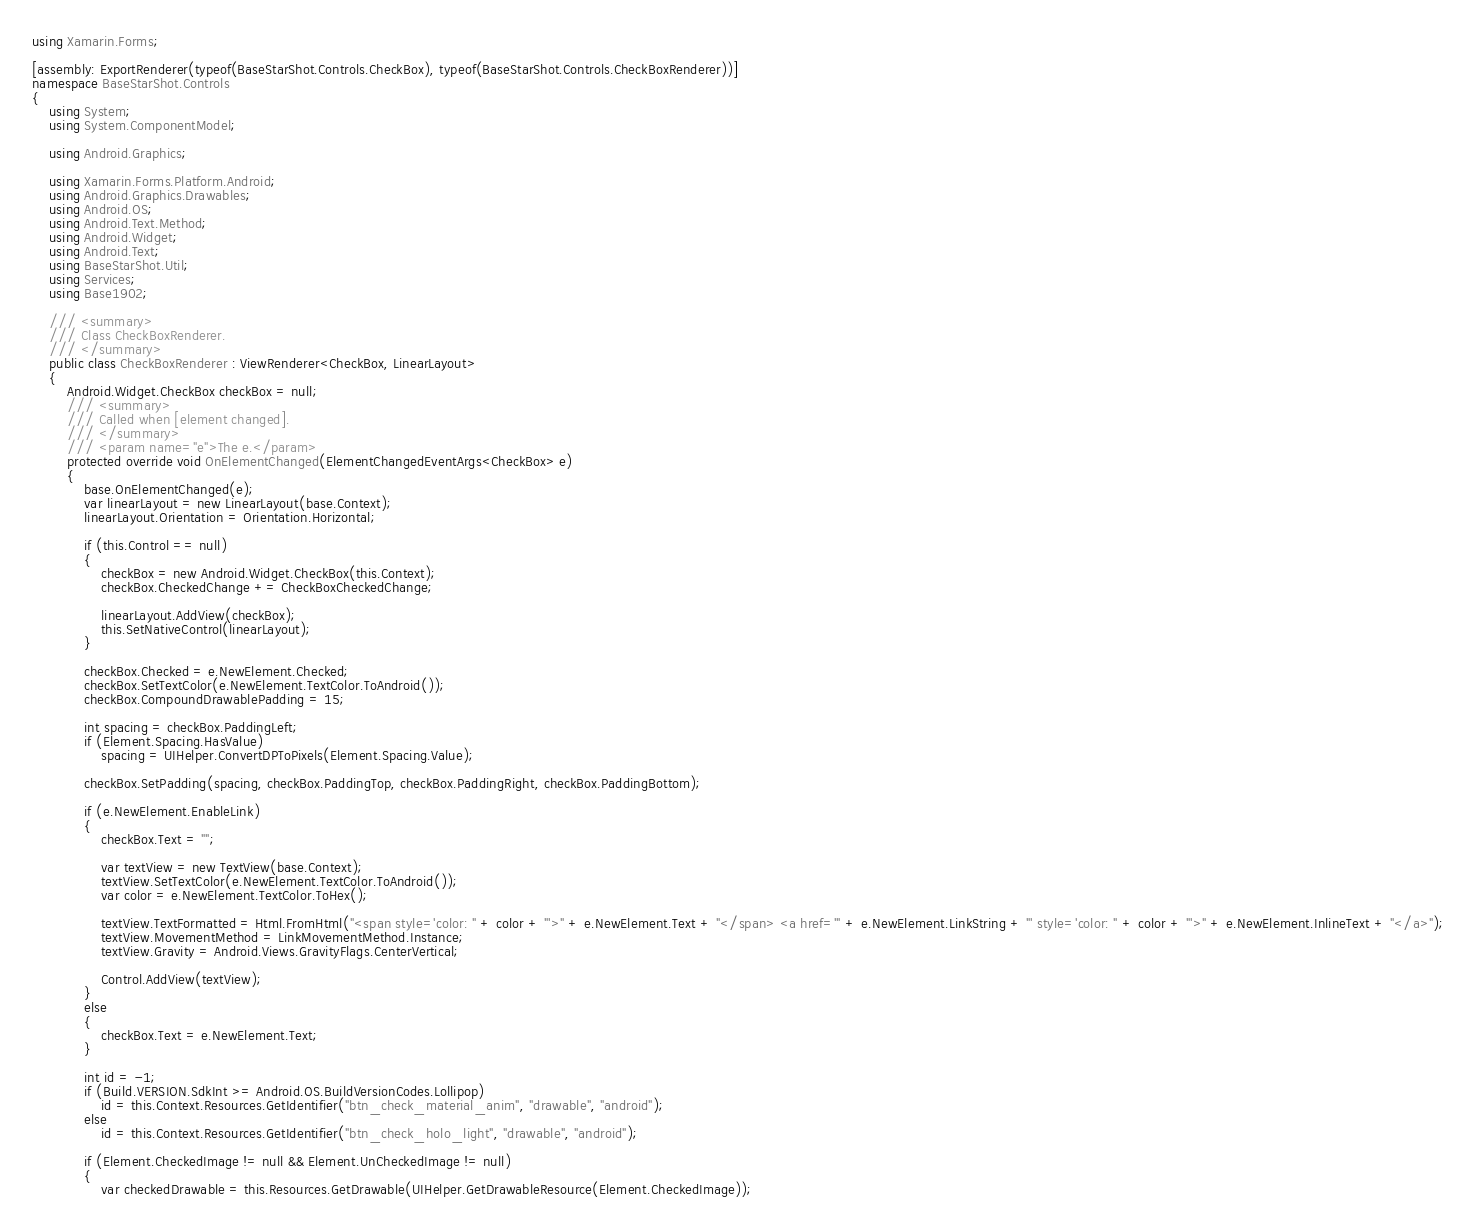<code> <loc_0><loc_0><loc_500><loc_500><_C#_>using Xamarin.Forms;

[assembly: ExportRenderer(typeof(BaseStarShot.Controls.CheckBox), typeof(BaseStarShot.Controls.CheckBoxRenderer))]
namespace BaseStarShot.Controls
{
    using System;
    using System.ComponentModel;

    using Android.Graphics;

    using Xamarin.Forms.Platform.Android;
    using Android.Graphics.Drawables;
    using Android.OS;
    using Android.Text.Method;
    using Android.Widget;
    using Android.Text;
    using BaseStarShot.Util;
    using Services;
    using Base1902;

    /// <summary>
    /// Class CheckBoxRenderer.
    /// </summary>
    public class CheckBoxRenderer : ViewRenderer<CheckBox, LinearLayout>
    {
        Android.Widget.CheckBox checkBox = null;
        /// <summary>
        /// Called when [element changed].
        /// </summary>
        /// <param name="e">The e.</param>
        protected override void OnElementChanged(ElementChangedEventArgs<CheckBox> e)
        {
            base.OnElementChanged(e);
            var linearLayout = new LinearLayout(base.Context);
            linearLayout.Orientation = Orientation.Horizontal;

            if (this.Control == null)
            {
                checkBox = new Android.Widget.CheckBox(this.Context);
                checkBox.CheckedChange += CheckBoxCheckedChange;

                linearLayout.AddView(checkBox);
                this.SetNativeControl(linearLayout);
            }

            checkBox.Checked = e.NewElement.Checked;
            checkBox.SetTextColor(e.NewElement.TextColor.ToAndroid());
            checkBox.CompoundDrawablePadding = 15;

            int spacing = checkBox.PaddingLeft;
            if (Element.Spacing.HasValue)
                spacing = UIHelper.ConvertDPToPixels(Element.Spacing.Value);

            checkBox.SetPadding(spacing, checkBox.PaddingTop, checkBox.PaddingRight, checkBox.PaddingBottom);

            if (e.NewElement.EnableLink)
            {
                checkBox.Text = "";

                var textView = new TextView(base.Context);
                textView.SetTextColor(e.NewElement.TextColor.ToAndroid());
                var color = e.NewElement.TextColor.ToHex();

                textView.TextFormatted = Html.FromHtml("<span style='color: " + color + "'>" + e.NewElement.Text + "</span> <a href='" + e.NewElement.LinkString + "' style='color: " + color + "'>" + e.NewElement.InlineText + "</a>");
                textView.MovementMethod = LinkMovementMethod.Instance;
                textView.Gravity = Android.Views.GravityFlags.CenterVertical;

                Control.AddView(textView);
            }
            else
            {
                checkBox.Text = e.NewElement.Text;
            }

            int id = -1;
            if (Build.VERSION.SdkInt >= Android.OS.BuildVersionCodes.Lollipop)
                id = this.Context.Resources.GetIdentifier("btn_check_material_anim", "drawable", "android");
            else
                id = this.Context.Resources.GetIdentifier("btn_check_holo_light", "drawable", "android");

            if (Element.CheckedImage != null && Element.UnCheckedImage != null)
            {
                var checkedDrawable = this.Resources.GetDrawable(UIHelper.GetDrawableResource(Element.CheckedImage));</code> 